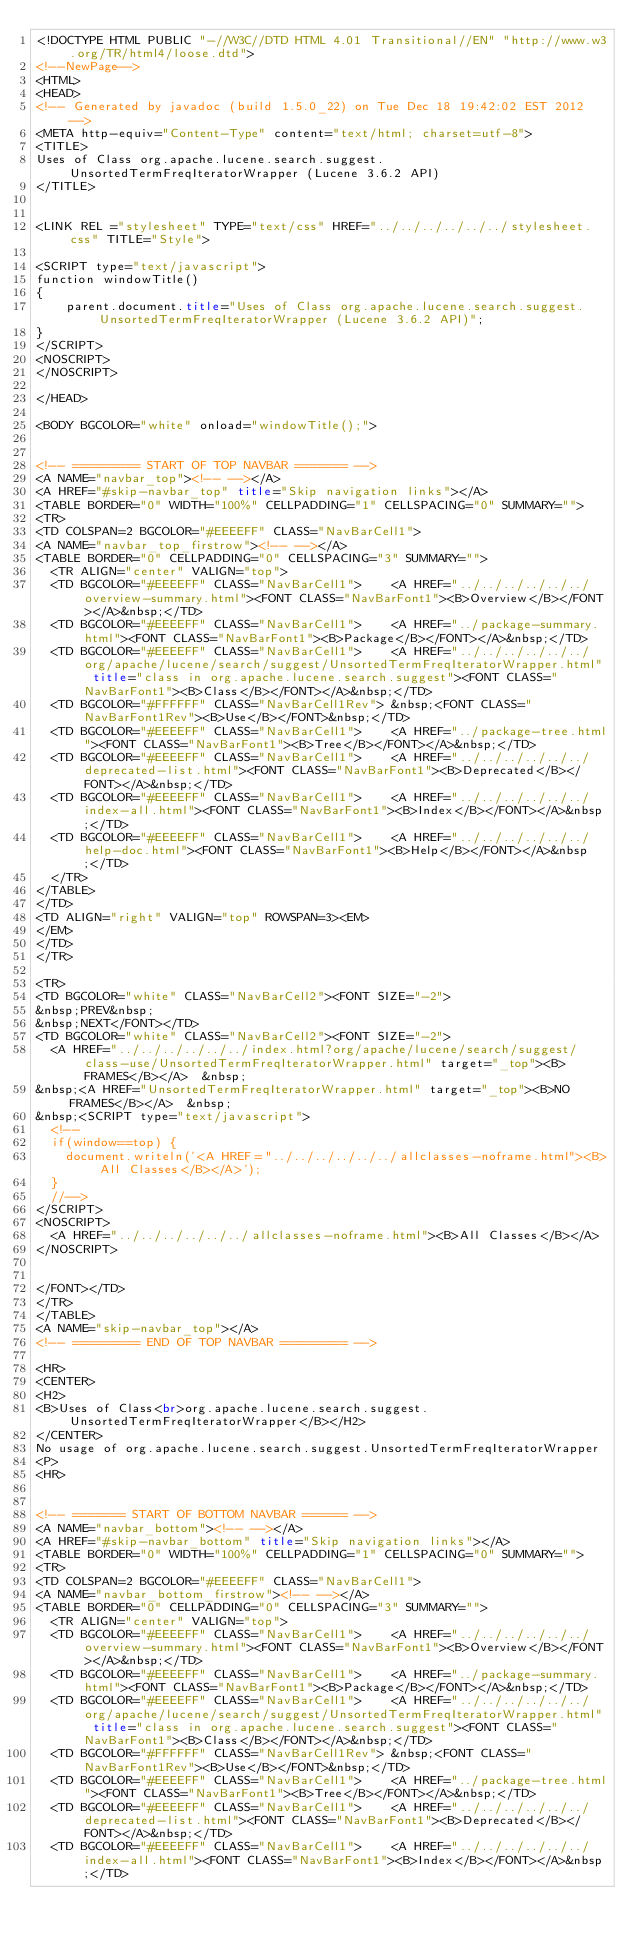<code> <loc_0><loc_0><loc_500><loc_500><_HTML_><!DOCTYPE HTML PUBLIC "-//W3C//DTD HTML 4.01 Transitional//EN" "http://www.w3.org/TR/html4/loose.dtd">
<!--NewPage-->
<HTML>
<HEAD>
<!-- Generated by javadoc (build 1.5.0_22) on Tue Dec 18 19:42:02 EST 2012 -->
<META http-equiv="Content-Type" content="text/html; charset=utf-8">
<TITLE>
Uses of Class org.apache.lucene.search.suggest.UnsortedTermFreqIteratorWrapper (Lucene 3.6.2 API)
</TITLE>


<LINK REL ="stylesheet" TYPE="text/css" HREF="../../../../../../stylesheet.css" TITLE="Style">

<SCRIPT type="text/javascript">
function windowTitle()
{
    parent.document.title="Uses of Class org.apache.lucene.search.suggest.UnsortedTermFreqIteratorWrapper (Lucene 3.6.2 API)";
}
</SCRIPT>
<NOSCRIPT>
</NOSCRIPT>

</HEAD>

<BODY BGCOLOR="white" onload="windowTitle();">


<!-- ========= START OF TOP NAVBAR ======= -->
<A NAME="navbar_top"><!-- --></A>
<A HREF="#skip-navbar_top" title="Skip navigation links"></A>
<TABLE BORDER="0" WIDTH="100%" CELLPADDING="1" CELLSPACING="0" SUMMARY="">
<TR>
<TD COLSPAN=2 BGCOLOR="#EEEEFF" CLASS="NavBarCell1">
<A NAME="navbar_top_firstrow"><!-- --></A>
<TABLE BORDER="0" CELLPADDING="0" CELLSPACING="3" SUMMARY="">
  <TR ALIGN="center" VALIGN="top">
  <TD BGCOLOR="#EEEEFF" CLASS="NavBarCell1">    <A HREF="../../../../../../overview-summary.html"><FONT CLASS="NavBarFont1"><B>Overview</B></FONT></A>&nbsp;</TD>
  <TD BGCOLOR="#EEEEFF" CLASS="NavBarCell1">    <A HREF="../package-summary.html"><FONT CLASS="NavBarFont1"><B>Package</B></FONT></A>&nbsp;</TD>
  <TD BGCOLOR="#EEEEFF" CLASS="NavBarCell1">    <A HREF="../../../../../../org/apache/lucene/search/suggest/UnsortedTermFreqIteratorWrapper.html" title="class in org.apache.lucene.search.suggest"><FONT CLASS="NavBarFont1"><B>Class</B></FONT></A>&nbsp;</TD>
  <TD BGCOLOR="#FFFFFF" CLASS="NavBarCell1Rev"> &nbsp;<FONT CLASS="NavBarFont1Rev"><B>Use</B></FONT>&nbsp;</TD>
  <TD BGCOLOR="#EEEEFF" CLASS="NavBarCell1">    <A HREF="../package-tree.html"><FONT CLASS="NavBarFont1"><B>Tree</B></FONT></A>&nbsp;</TD>
  <TD BGCOLOR="#EEEEFF" CLASS="NavBarCell1">    <A HREF="../../../../../../deprecated-list.html"><FONT CLASS="NavBarFont1"><B>Deprecated</B></FONT></A>&nbsp;</TD>
  <TD BGCOLOR="#EEEEFF" CLASS="NavBarCell1">    <A HREF="../../../../../../index-all.html"><FONT CLASS="NavBarFont1"><B>Index</B></FONT></A>&nbsp;</TD>
  <TD BGCOLOR="#EEEEFF" CLASS="NavBarCell1">    <A HREF="../../../../../../help-doc.html"><FONT CLASS="NavBarFont1"><B>Help</B></FONT></A>&nbsp;</TD>
  </TR>
</TABLE>
</TD>
<TD ALIGN="right" VALIGN="top" ROWSPAN=3><EM>
</EM>
</TD>
</TR>

<TR>
<TD BGCOLOR="white" CLASS="NavBarCell2"><FONT SIZE="-2">
&nbsp;PREV&nbsp;
&nbsp;NEXT</FONT></TD>
<TD BGCOLOR="white" CLASS="NavBarCell2"><FONT SIZE="-2">
  <A HREF="../../../../../../index.html?org/apache/lucene/search/suggest/class-use/UnsortedTermFreqIteratorWrapper.html" target="_top"><B>FRAMES</B></A>  &nbsp;
&nbsp;<A HREF="UnsortedTermFreqIteratorWrapper.html" target="_top"><B>NO FRAMES</B></A>  &nbsp;
&nbsp;<SCRIPT type="text/javascript">
  <!--
  if(window==top) {
    document.writeln('<A HREF="../../../../../../allclasses-noframe.html"><B>All Classes</B></A>');
  }
  //-->
</SCRIPT>
<NOSCRIPT>
  <A HREF="../../../../../../allclasses-noframe.html"><B>All Classes</B></A>
</NOSCRIPT>


</FONT></TD>
</TR>
</TABLE>
<A NAME="skip-navbar_top"></A>
<!-- ========= END OF TOP NAVBAR ========= -->

<HR>
<CENTER>
<H2>
<B>Uses of Class<br>org.apache.lucene.search.suggest.UnsortedTermFreqIteratorWrapper</B></H2>
</CENTER>
No usage of org.apache.lucene.search.suggest.UnsortedTermFreqIteratorWrapper
<P>
<HR>


<!-- ======= START OF BOTTOM NAVBAR ====== -->
<A NAME="navbar_bottom"><!-- --></A>
<A HREF="#skip-navbar_bottom" title="Skip navigation links"></A>
<TABLE BORDER="0" WIDTH="100%" CELLPADDING="1" CELLSPACING="0" SUMMARY="">
<TR>
<TD COLSPAN=2 BGCOLOR="#EEEEFF" CLASS="NavBarCell1">
<A NAME="navbar_bottom_firstrow"><!-- --></A>
<TABLE BORDER="0" CELLPADDING="0" CELLSPACING="3" SUMMARY="">
  <TR ALIGN="center" VALIGN="top">
  <TD BGCOLOR="#EEEEFF" CLASS="NavBarCell1">    <A HREF="../../../../../../overview-summary.html"><FONT CLASS="NavBarFont1"><B>Overview</B></FONT></A>&nbsp;</TD>
  <TD BGCOLOR="#EEEEFF" CLASS="NavBarCell1">    <A HREF="../package-summary.html"><FONT CLASS="NavBarFont1"><B>Package</B></FONT></A>&nbsp;</TD>
  <TD BGCOLOR="#EEEEFF" CLASS="NavBarCell1">    <A HREF="../../../../../../org/apache/lucene/search/suggest/UnsortedTermFreqIteratorWrapper.html" title="class in org.apache.lucene.search.suggest"><FONT CLASS="NavBarFont1"><B>Class</B></FONT></A>&nbsp;</TD>
  <TD BGCOLOR="#FFFFFF" CLASS="NavBarCell1Rev"> &nbsp;<FONT CLASS="NavBarFont1Rev"><B>Use</B></FONT>&nbsp;</TD>
  <TD BGCOLOR="#EEEEFF" CLASS="NavBarCell1">    <A HREF="../package-tree.html"><FONT CLASS="NavBarFont1"><B>Tree</B></FONT></A>&nbsp;</TD>
  <TD BGCOLOR="#EEEEFF" CLASS="NavBarCell1">    <A HREF="../../../../../../deprecated-list.html"><FONT CLASS="NavBarFont1"><B>Deprecated</B></FONT></A>&nbsp;</TD>
  <TD BGCOLOR="#EEEEFF" CLASS="NavBarCell1">    <A HREF="../../../../../../index-all.html"><FONT CLASS="NavBarFont1"><B>Index</B></FONT></A>&nbsp;</TD></code> 